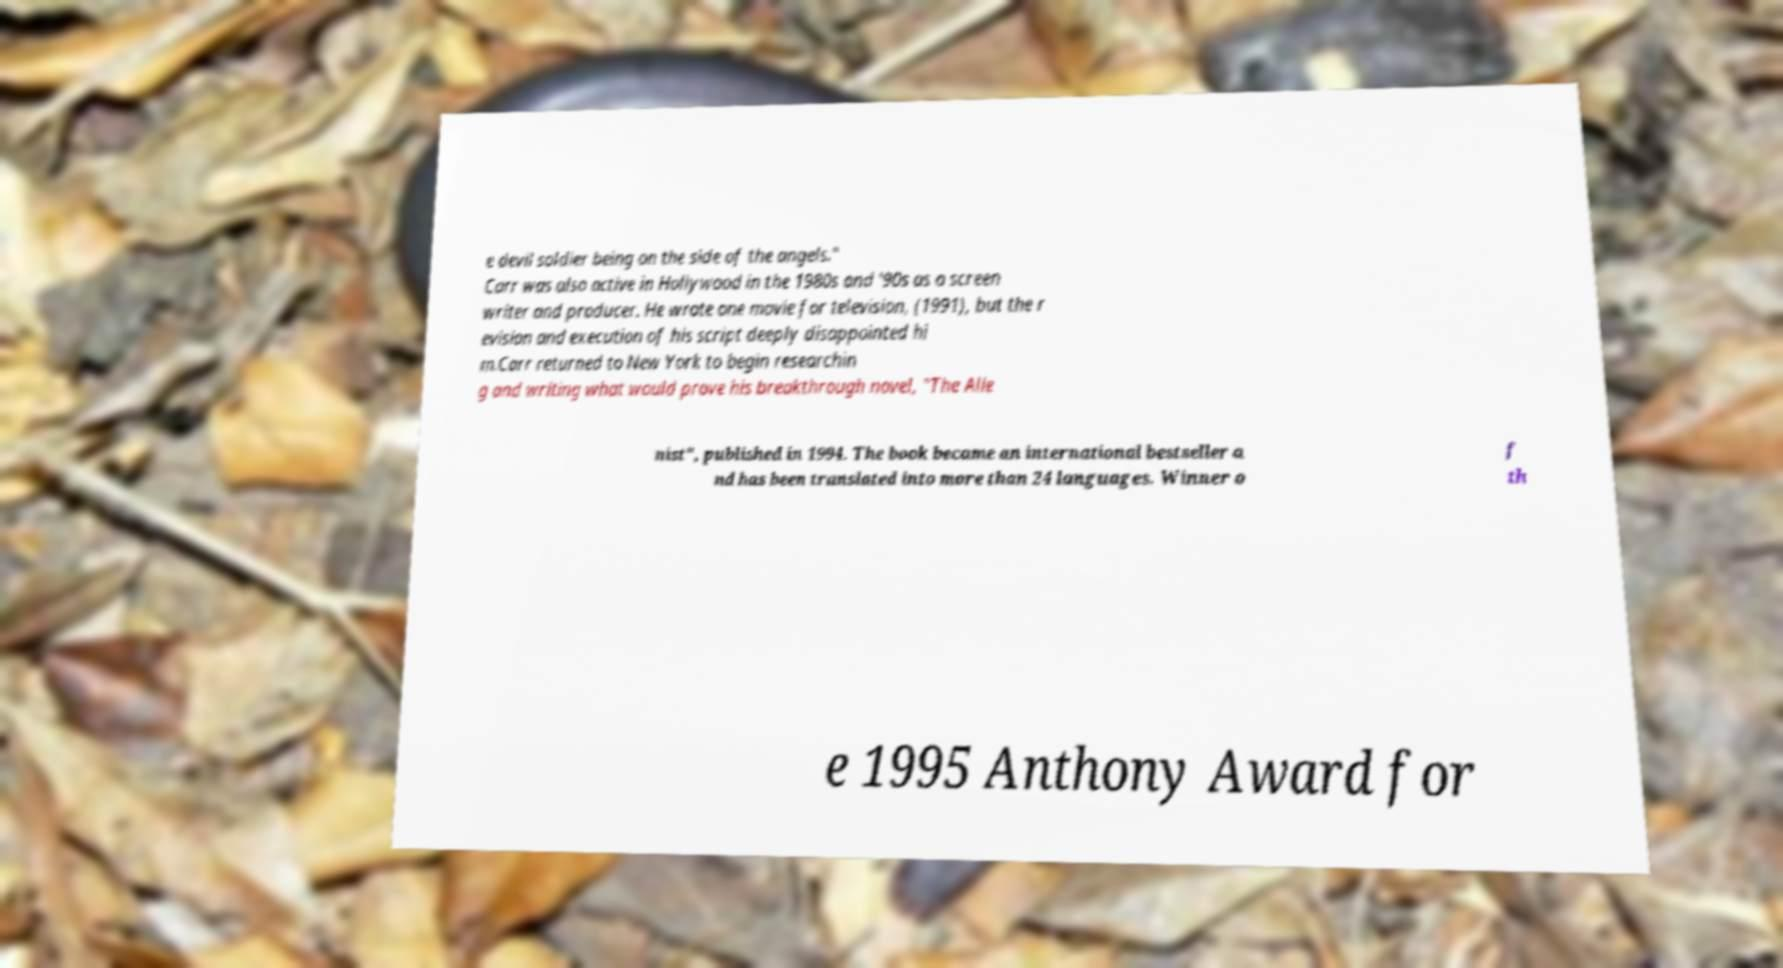Could you extract and type out the text from this image? e devil soldier being on the side of the angels." Carr was also active in Hollywood in the 1980s and '90s as a screen writer and producer. He wrote one movie for television, (1991), but the r evision and execution of his script deeply disappointed hi m.Carr returned to New York to begin researchin g and writing what would prove his breakthrough novel, "The Alie nist", published in 1994. The book became an international bestseller a nd has been translated into more than 24 languages. Winner o f th e 1995 Anthony Award for 